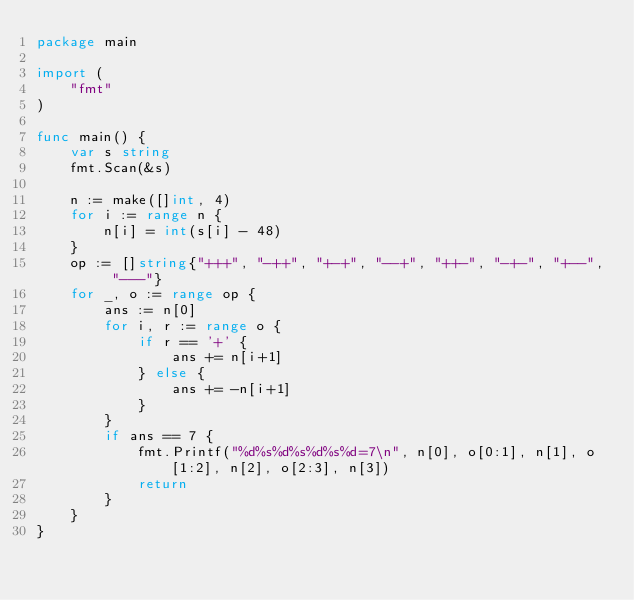Convert code to text. <code><loc_0><loc_0><loc_500><loc_500><_Go_>package main

import (
	"fmt"
)

func main() {
	var s string
	fmt.Scan(&s)

	n := make([]int, 4)
	for i := range n {
		n[i] = int(s[i] - 48)
	}
	op := []string{"+++", "-++", "+-+", "--+", "++-", "-+-", "+--", "---"}
	for _, o := range op {
		ans := n[0]
		for i, r := range o {
			if r == '+' {
				ans += n[i+1]
			} else {
				ans += -n[i+1]
			}
		}
		if ans == 7 {
			fmt.Printf("%d%s%d%s%d%s%d=7\n", n[0], o[0:1], n[1], o[1:2], n[2], o[2:3], n[3])
			return
		}
	}
}
</code> 